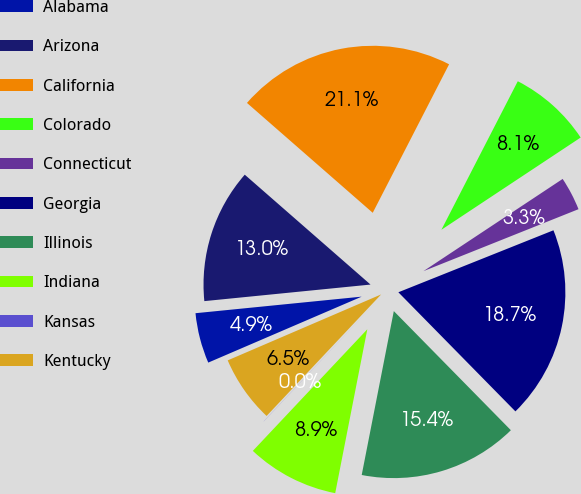<chart> <loc_0><loc_0><loc_500><loc_500><pie_chart><fcel>Alabama<fcel>Arizona<fcel>California<fcel>Colorado<fcel>Connecticut<fcel>Georgia<fcel>Illinois<fcel>Indiana<fcel>Kansas<fcel>Kentucky<nl><fcel>4.88%<fcel>13.01%<fcel>21.13%<fcel>8.13%<fcel>3.26%<fcel>18.69%<fcel>15.44%<fcel>8.94%<fcel>0.01%<fcel>6.51%<nl></chart> 